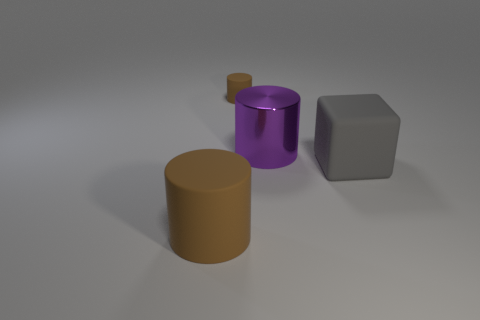Add 1 large red shiny things. How many objects exist? 5 Subtract all cubes. How many objects are left? 3 Add 2 large matte objects. How many large matte objects exist? 4 Subtract 0 yellow balls. How many objects are left? 4 Subtract all gray objects. Subtract all large yellow metal balls. How many objects are left? 3 Add 4 purple things. How many purple things are left? 5 